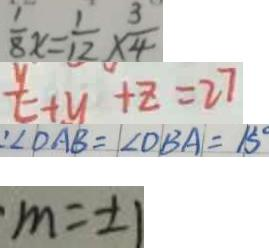Convert formula to latex. <formula><loc_0><loc_0><loc_500><loc_500>\frac { 1 } { 8 } x = \frac { 1 } { 1 2 } \times \frac { 3 } { 4 } 
 \frac { y } { t } + y + z = 2 7 
 \angle D A B = \angle D B A = 1 5 ^ { \circ } 
 m = \pm 1</formula> 